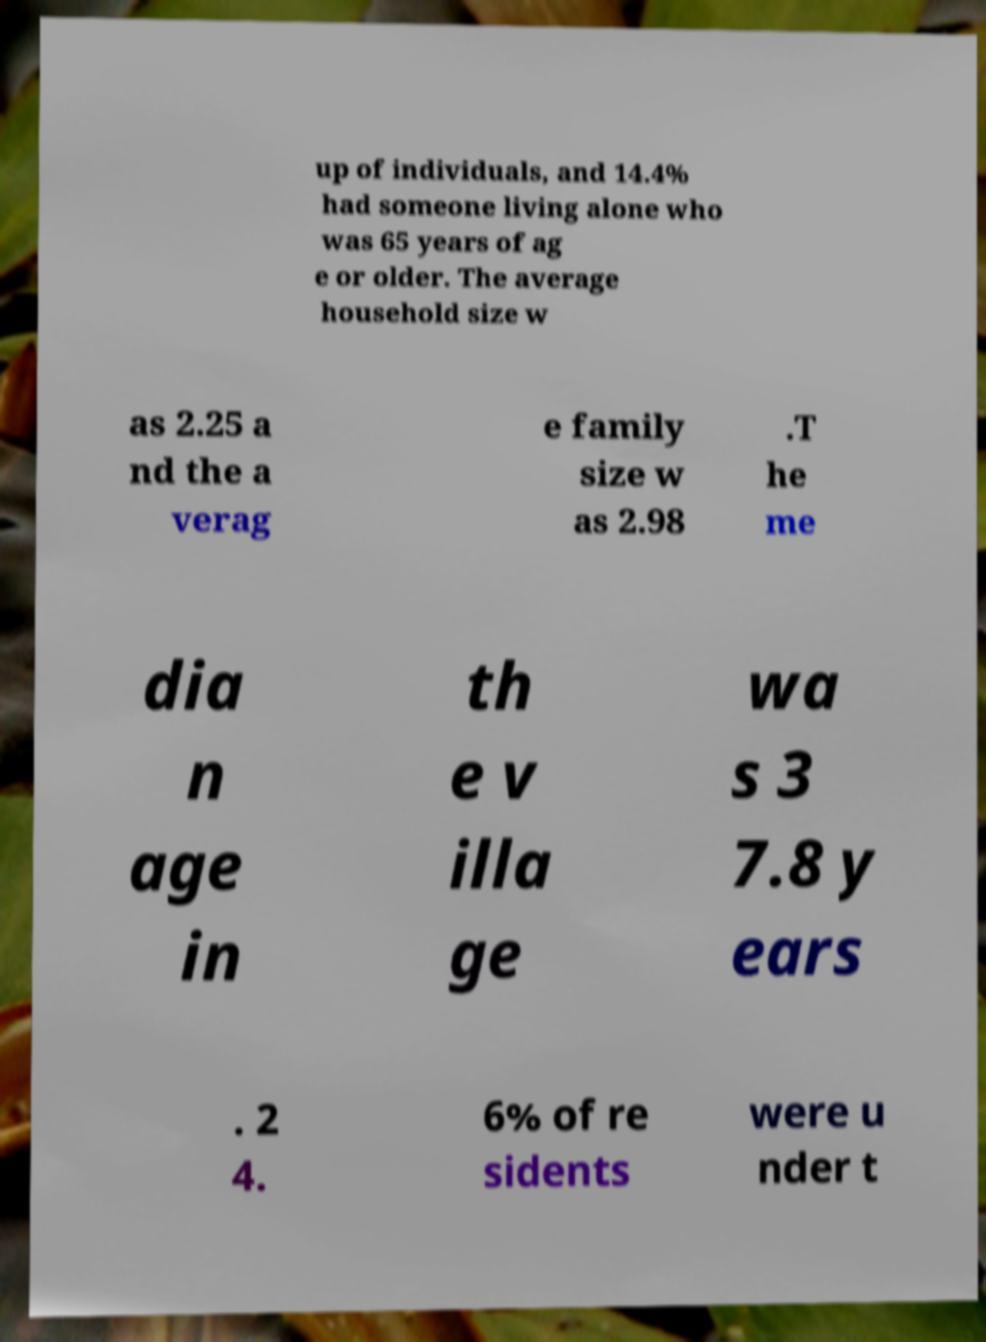I need the written content from this picture converted into text. Can you do that? up of individuals, and 14.4% had someone living alone who was 65 years of ag e or older. The average household size w as 2.25 a nd the a verag e family size w as 2.98 .T he me dia n age in th e v illa ge wa s 3 7.8 y ears . 2 4. 6% of re sidents were u nder t 